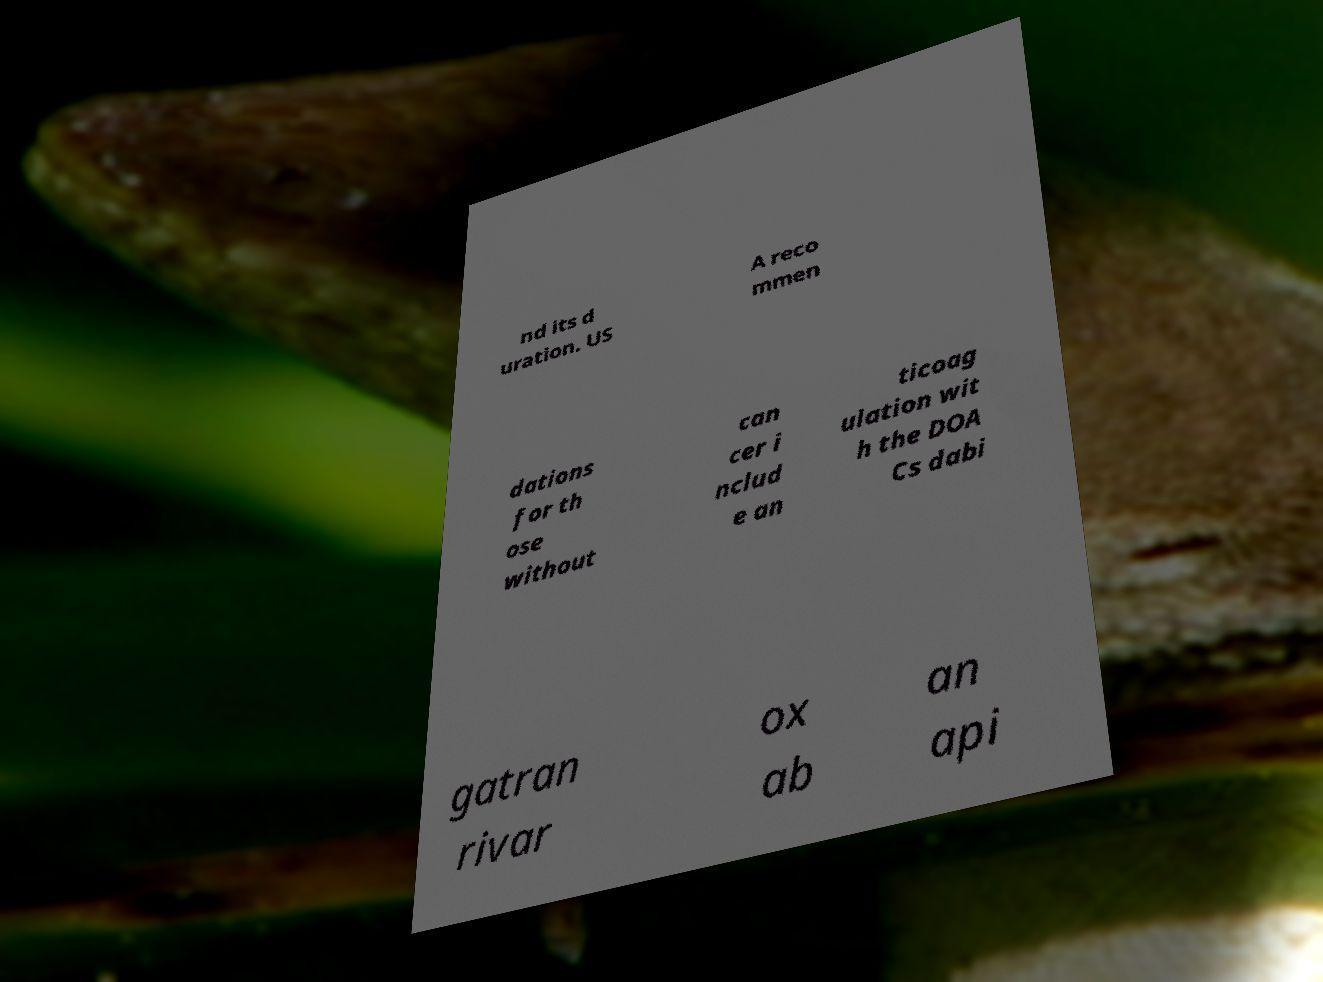What messages or text are displayed in this image? I need them in a readable, typed format. nd its d uration. US A reco mmen dations for th ose without can cer i nclud e an ticoag ulation wit h the DOA Cs dabi gatran rivar ox ab an api 